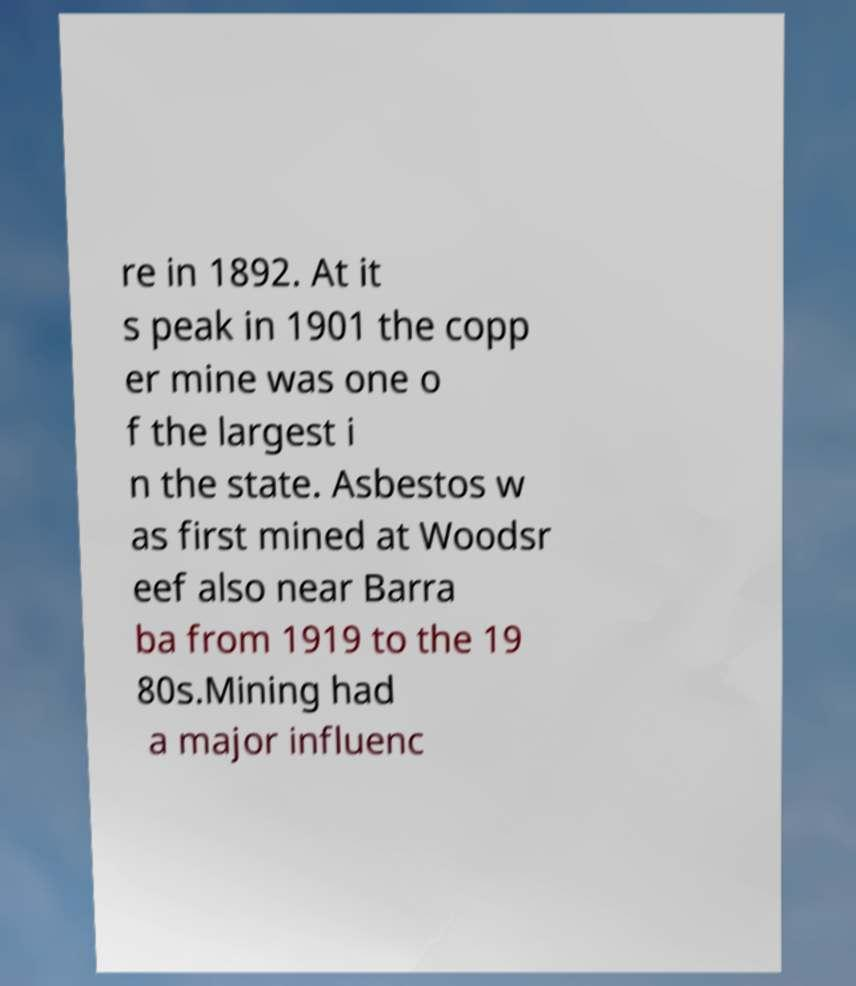There's text embedded in this image that I need extracted. Can you transcribe it verbatim? re in 1892. At it s peak in 1901 the copp er mine was one o f the largest i n the state. Asbestos w as first mined at Woodsr eef also near Barra ba from 1919 to the 19 80s.Mining had a major influenc 